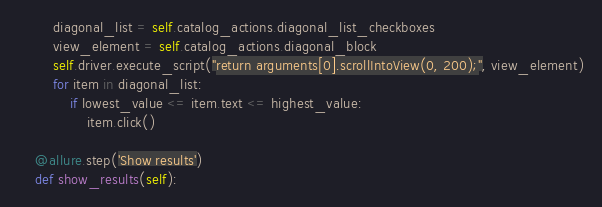<code> <loc_0><loc_0><loc_500><loc_500><_Python_>        diagonal_list = self.catalog_actions.diagonal_list_checkboxes
        view_element = self.catalog_actions.diagonal_block
        self.driver.execute_script("return arguments[0].scrollIntoView(0, 200);", view_element)
        for item in diagonal_list:
            if lowest_value <= item.text <= highest_value:
                item.click()

    @allure.step('Show results')
    def show_results(self):</code> 